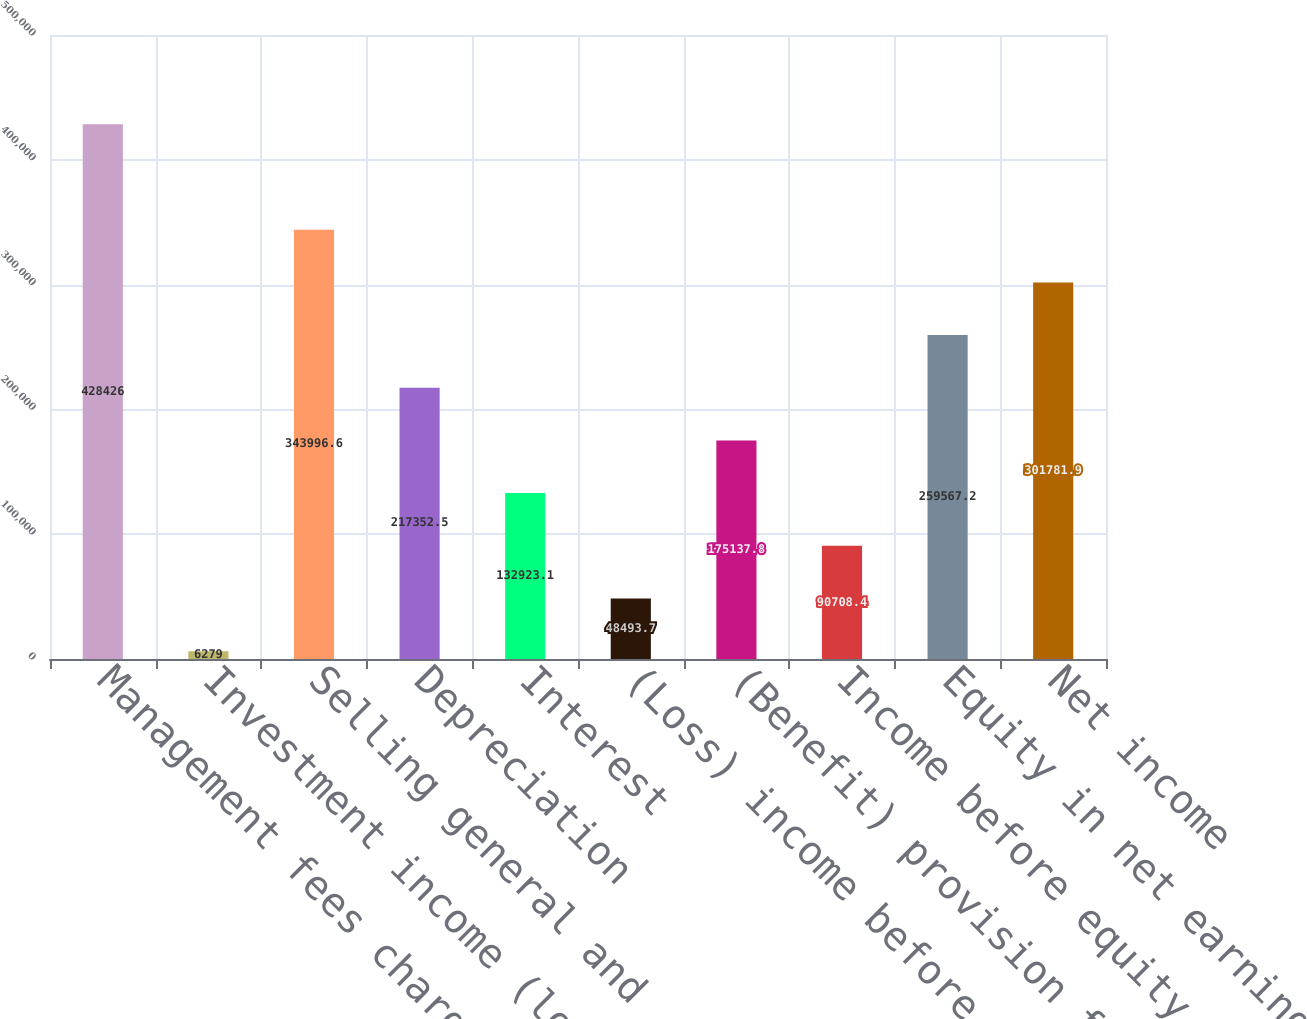<chart> <loc_0><loc_0><loc_500><loc_500><bar_chart><fcel>Management fees charged to<fcel>Investment income (loss) and<fcel>Selling general and<fcel>Depreciation<fcel>Interest<fcel>(Loss) income before income<fcel>(Benefit) provision for income<fcel>Income before equity in net<fcel>Equity in net earnings of<fcel>Net income<nl><fcel>428426<fcel>6279<fcel>343997<fcel>217352<fcel>132923<fcel>48493.7<fcel>175138<fcel>90708.4<fcel>259567<fcel>301782<nl></chart> 